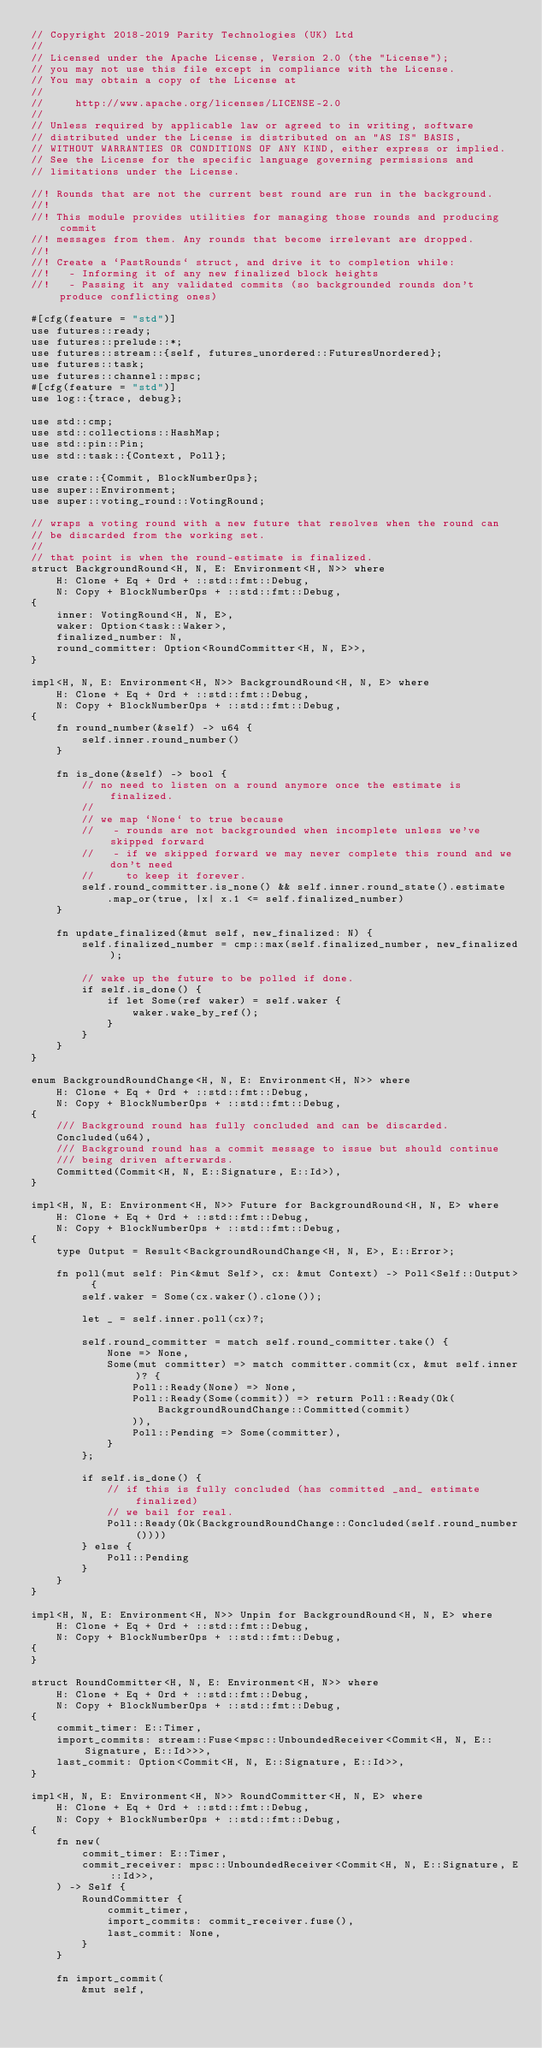<code> <loc_0><loc_0><loc_500><loc_500><_Rust_>// Copyright 2018-2019 Parity Technologies (UK) Ltd
//
// Licensed under the Apache License, Version 2.0 (the "License");
// you may not use this file except in compliance with the License.
// You may obtain a copy of the License at
//
//     http://www.apache.org/licenses/LICENSE-2.0
//
// Unless required by applicable law or agreed to in writing, software
// distributed under the License is distributed on an "AS IS" BASIS,
// WITHOUT WARRANTIES OR CONDITIONS OF ANY KIND, either express or implied.
// See the License for the specific language governing permissions and
// limitations under the License.

//! Rounds that are not the current best round are run in the background.
//!
//! This module provides utilities for managing those rounds and producing commit
//! messages from them. Any rounds that become irrelevant are dropped.
//!
//! Create a `PastRounds` struct, and drive it to completion while:
//!   - Informing it of any new finalized block heights
//!   - Passing it any validated commits (so backgrounded rounds don't produce conflicting ones)

#[cfg(feature = "std")]
use futures::ready;
use futures::prelude::*;
use futures::stream::{self, futures_unordered::FuturesUnordered};
use futures::task;
use futures::channel::mpsc;
#[cfg(feature = "std")]
use log::{trace, debug};

use std::cmp;
use std::collections::HashMap;
use std::pin::Pin;
use std::task::{Context, Poll};

use crate::{Commit, BlockNumberOps};
use super::Environment;
use super::voting_round::VotingRound;

// wraps a voting round with a new future that resolves when the round can
// be discarded from the working set.
//
// that point is when the round-estimate is finalized.
struct BackgroundRound<H, N, E: Environment<H, N>> where
	H: Clone + Eq + Ord + ::std::fmt::Debug,
	N: Copy + BlockNumberOps + ::std::fmt::Debug,
{
	inner: VotingRound<H, N, E>,
	waker: Option<task::Waker>,
	finalized_number: N,
	round_committer: Option<RoundCommitter<H, N, E>>,
}

impl<H, N, E: Environment<H, N>> BackgroundRound<H, N, E> where
	H: Clone + Eq + Ord + ::std::fmt::Debug,
	N: Copy + BlockNumberOps + ::std::fmt::Debug,
{
	fn round_number(&self) -> u64 {
		self.inner.round_number()
	}

	fn is_done(&self) -> bool {
		// no need to listen on a round anymore once the estimate is finalized.
		//
		// we map `None` to true because
		//   - rounds are not backgrounded when incomplete unless we've skipped forward
		//   - if we skipped forward we may never complete this round and we don't need
		//     to keep it forever.
		self.round_committer.is_none() && self.inner.round_state().estimate
			.map_or(true, |x| x.1 <= self.finalized_number)
	}

	fn update_finalized(&mut self, new_finalized: N) {
		self.finalized_number = cmp::max(self.finalized_number, new_finalized);

		// wake up the future to be polled if done.
		if self.is_done() {
			if let Some(ref waker) = self.waker {
				waker.wake_by_ref();
			}
		}
	}
}

enum BackgroundRoundChange<H, N, E: Environment<H, N>> where
	H: Clone + Eq + Ord + ::std::fmt::Debug,
	N: Copy + BlockNumberOps + ::std::fmt::Debug,
{
	/// Background round has fully concluded and can be discarded.
	Concluded(u64),
	/// Background round has a commit message to issue but should continue
	/// being driven afterwards.
	Committed(Commit<H, N, E::Signature, E::Id>),
}

impl<H, N, E: Environment<H, N>> Future for BackgroundRound<H, N, E> where
	H: Clone + Eq + Ord + ::std::fmt::Debug,
	N: Copy + BlockNumberOps + ::std::fmt::Debug,
{
	type Output = Result<BackgroundRoundChange<H, N, E>, E::Error>;

	fn poll(mut self: Pin<&mut Self>, cx: &mut Context) -> Poll<Self::Output> {
		self.waker = Some(cx.waker().clone());

		let _ = self.inner.poll(cx)?;

		self.round_committer = match self.round_committer.take() {
			None => None,
			Some(mut committer) => match committer.commit(cx, &mut self.inner)? {
				Poll::Ready(None) => None,
				Poll::Ready(Some(commit)) => return Poll::Ready(Ok(
					BackgroundRoundChange::Committed(commit)
				)),
				Poll::Pending => Some(committer),
			}
		};

		if self.is_done() {
			// if this is fully concluded (has committed _and_ estimate finalized)
			// we bail for real.
			Poll::Ready(Ok(BackgroundRoundChange::Concluded(self.round_number())))
		} else {
			Poll::Pending
		}
	}
}

impl<H, N, E: Environment<H, N>> Unpin for BackgroundRound<H, N, E> where
	H: Clone + Eq + Ord + ::std::fmt::Debug,
	N: Copy + BlockNumberOps + ::std::fmt::Debug,
{
}

struct RoundCommitter<H, N, E: Environment<H, N>> where
	H: Clone + Eq + Ord + ::std::fmt::Debug,
	N: Copy + BlockNumberOps + ::std::fmt::Debug,
{
	commit_timer: E::Timer,
	import_commits: stream::Fuse<mpsc::UnboundedReceiver<Commit<H, N, E::Signature, E::Id>>>,
	last_commit: Option<Commit<H, N, E::Signature, E::Id>>,
}

impl<H, N, E: Environment<H, N>> RoundCommitter<H, N, E> where
	H: Clone + Eq + Ord + ::std::fmt::Debug,
	N: Copy + BlockNumberOps + ::std::fmt::Debug,
{
	fn new(
		commit_timer: E::Timer,
		commit_receiver: mpsc::UnboundedReceiver<Commit<H, N, E::Signature, E::Id>>,
	) -> Self {
		RoundCommitter {
			commit_timer,
			import_commits: commit_receiver.fuse(),
			last_commit: None,
		}
	}

	fn import_commit(
		&mut self,</code> 